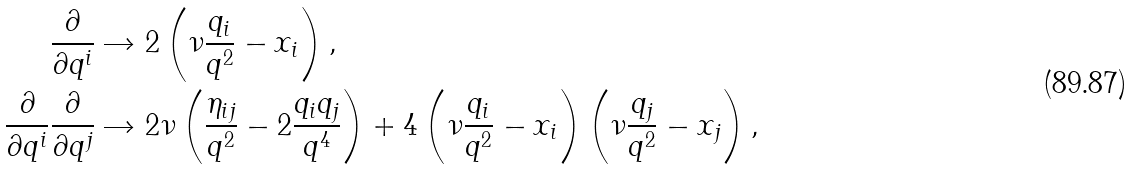Convert formula to latex. <formula><loc_0><loc_0><loc_500><loc_500>\frac { \partial } { \partial q ^ { i } } & \rightarrow 2 \left ( \nu \frac { q _ { i } } { q ^ { 2 } } - x _ { i } \right ) , \\ \frac { \partial } { \partial q ^ { i } } \frac { \partial } { \partial q ^ { j } } & \rightarrow 2 \nu \left ( \frac { \eta _ { i j } } { q ^ { 2 } } - 2 \frac { q _ { i } q _ { j } } { q ^ { 4 } } \right ) + 4 \left ( \nu \frac { q _ { i } } { q ^ { 2 } } - x _ { i } \right ) \left ( \nu \frac { q _ { j } } { q ^ { 2 } } - x _ { j } \right ) ,</formula> 